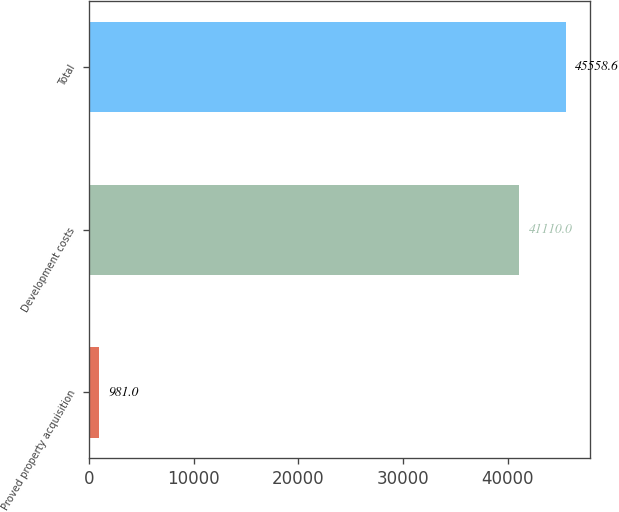Convert chart to OTSL. <chart><loc_0><loc_0><loc_500><loc_500><bar_chart><fcel>Proved property acquisition<fcel>Development costs<fcel>Total<nl><fcel>981<fcel>41110<fcel>45558.6<nl></chart> 